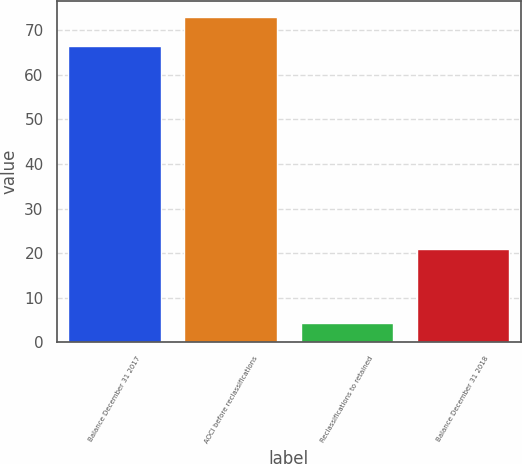Convert chart. <chart><loc_0><loc_0><loc_500><loc_500><bar_chart><fcel>Balance December 31 2017<fcel>AOCI before reclassifications<fcel>Reclassifications to retained<fcel>Balance December 31 2018<nl><fcel>66.5<fcel>72.88<fcel>4.4<fcel>20.9<nl></chart> 